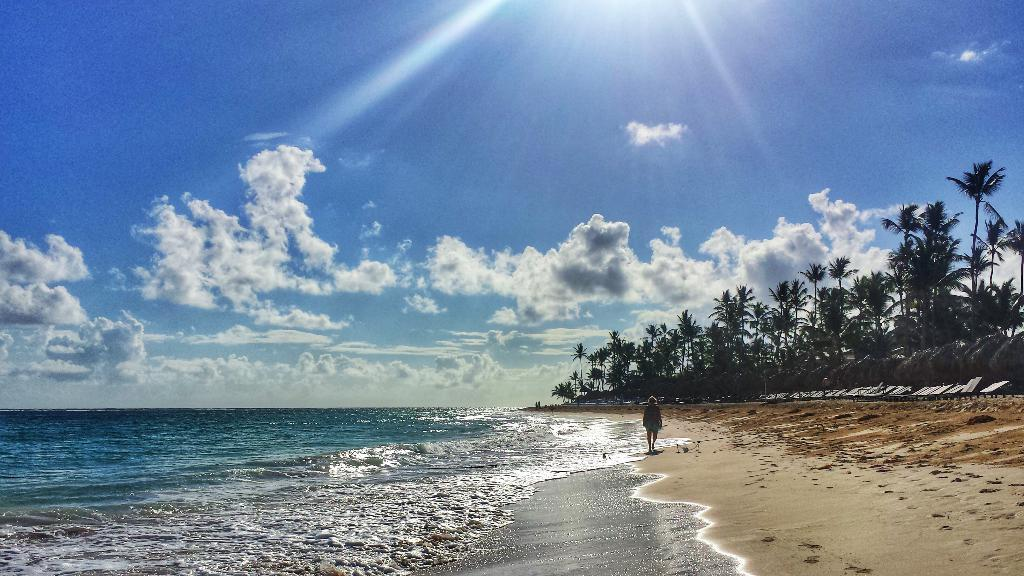What is the person in the image doing? The person is standing on the sea shore. What type of vegetation can be seen in the image? There are trees in the image. What objects are present on the sea shore? There are boards in the image. What is visible in the background of the image? The sky is visible in the background of the image. What can be observed in the sky? Clouds are present in the sky. What type of plantation is visible in the image? There is no plantation present in the image. What class is the person attending on the sea shore? There is no indication of a class or any educational activity in the image. 